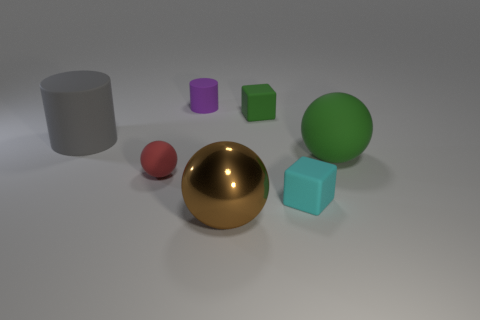What number of shiny things are blue cylinders or brown objects?
Offer a very short reply. 1. What is the shape of the small matte thing that is the same color as the large matte ball?
Keep it short and to the point. Cube. Does the cylinder right of the tiny matte ball have the same color as the large matte ball?
Provide a short and direct response. No. What shape is the green matte object that is in front of the green matte object that is to the left of the large green matte thing?
Your answer should be compact. Sphere. How many objects are either objects that are behind the big metallic sphere or rubber balls that are on the left side of the small purple cylinder?
Give a very brief answer. 6. What is the shape of the tiny purple object that is made of the same material as the large green sphere?
Provide a succinct answer. Cylinder. Is there any other thing that is the same color as the small ball?
Keep it short and to the point. No. There is another red thing that is the same shape as the big shiny object; what material is it?
Give a very brief answer. Rubber. What number of other things are the same size as the brown object?
Provide a short and direct response. 2. What material is the cyan block?
Make the answer very short. Rubber. 